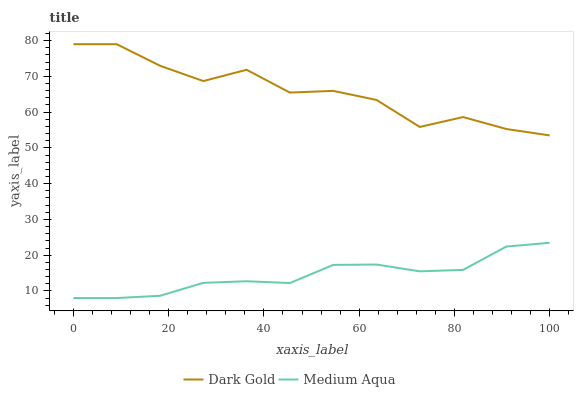Does Medium Aqua have the minimum area under the curve?
Answer yes or no. Yes. Does Dark Gold have the maximum area under the curve?
Answer yes or no. Yes. Does Dark Gold have the minimum area under the curve?
Answer yes or no. No. Is Medium Aqua the smoothest?
Answer yes or no. Yes. Is Dark Gold the roughest?
Answer yes or no. Yes. Is Dark Gold the smoothest?
Answer yes or no. No. Does Medium Aqua have the lowest value?
Answer yes or no. Yes. Does Dark Gold have the lowest value?
Answer yes or no. No. Does Dark Gold have the highest value?
Answer yes or no. Yes. Is Medium Aqua less than Dark Gold?
Answer yes or no. Yes. Is Dark Gold greater than Medium Aqua?
Answer yes or no. Yes. Does Medium Aqua intersect Dark Gold?
Answer yes or no. No. 